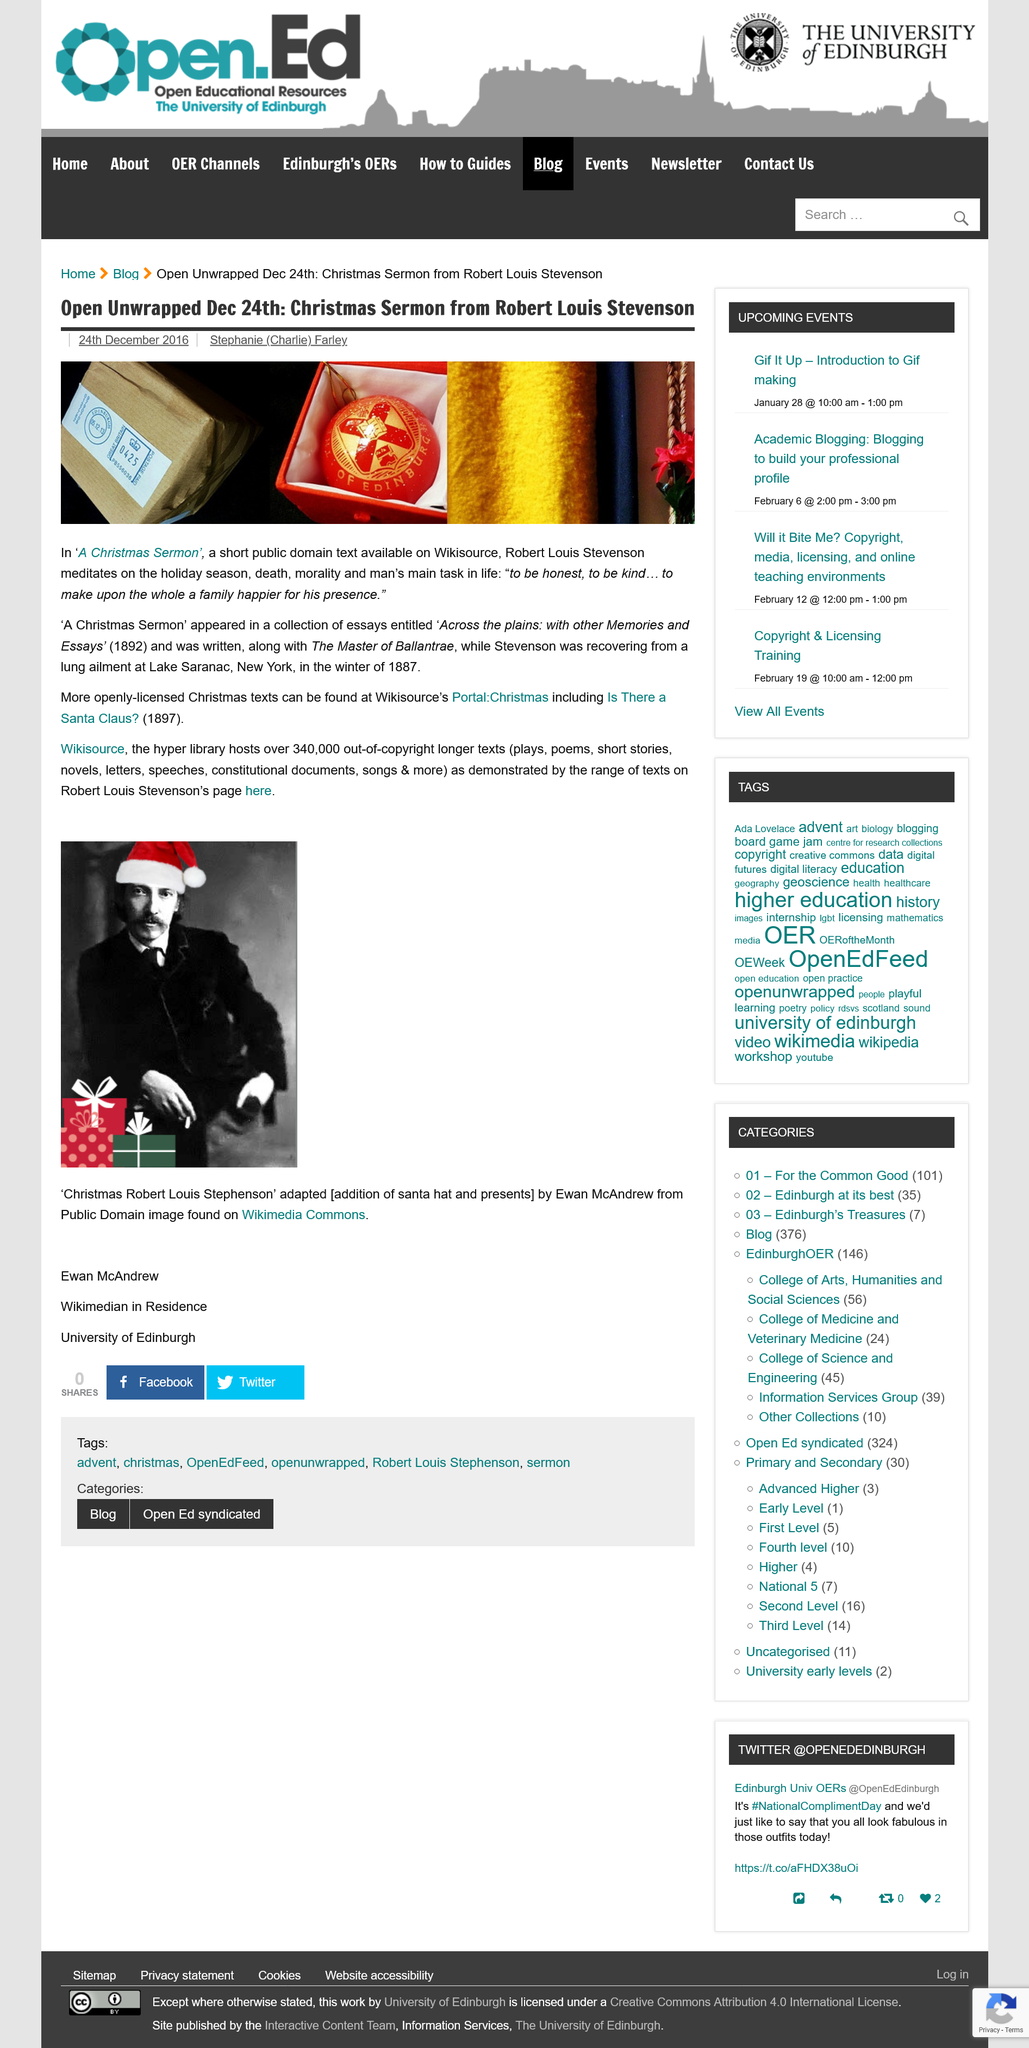Give some essential details in this illustration. Where can 'A Christmas Sermon' be found and what collection did it appear in? It is available on Wikisource and was included in the book 'Across the plains: with other Memories and Essays.' Robert Louis Stevenson wrote "A Christmas Sermon. 